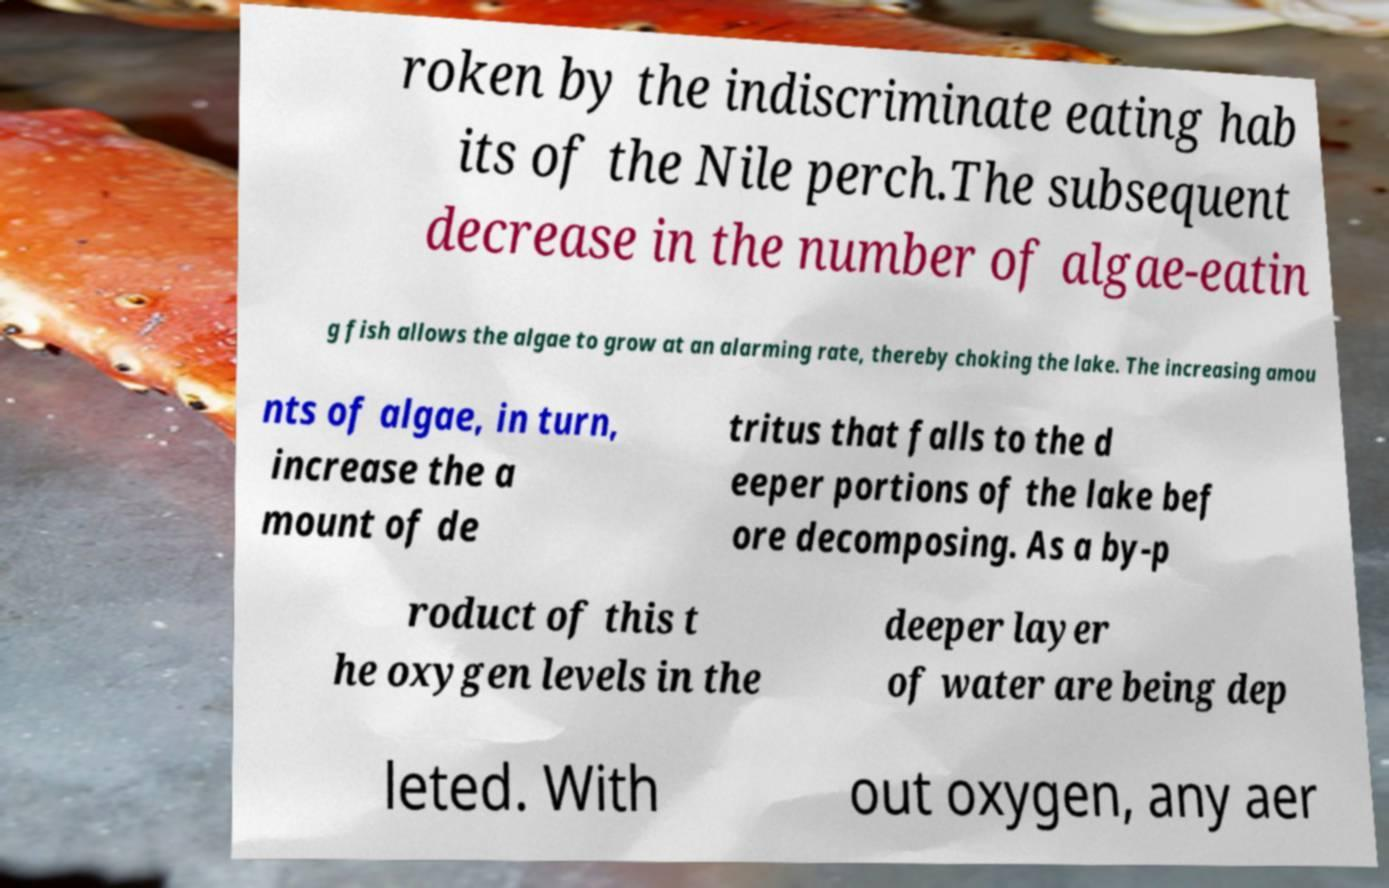Could you assist in decoding the text presented in this image and type it out clearly? roken by the indiscriminate eating hab its of the Nile perch.The subsequent decrease in the number of algae-eatin g fish allows the algae to grow at an alarming rate, thereby choking the lake. The increasing amou nts of algae, in turn, increase the a mount of de tritus that falls to the d eeper portions of the lake bef ore decomposing. As a by-p roduct of this t he oxygen levels in the deeper layer of water are being dep leted. With out oxygen, any aer 